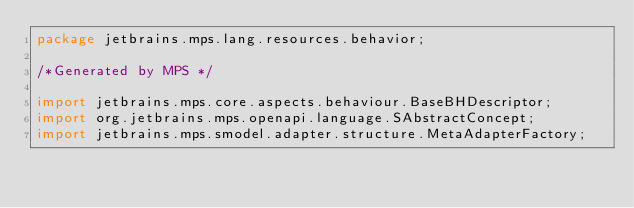Convert code to text. <code><loc_0><loc_0><loc_500><loc_500><_Java_>package jetbrains.mps.lang.resources.behavior;

/*Generated by MPS */

import jetbrains.mps.core.aspects.behaviour.BaseBHDescriptor;
import org.jetbrains.mps.openapi.language.SAbstractConcept;
import jetbrains.mps.smodel.adapter.structure.MetaAdapterFactory;</code> 